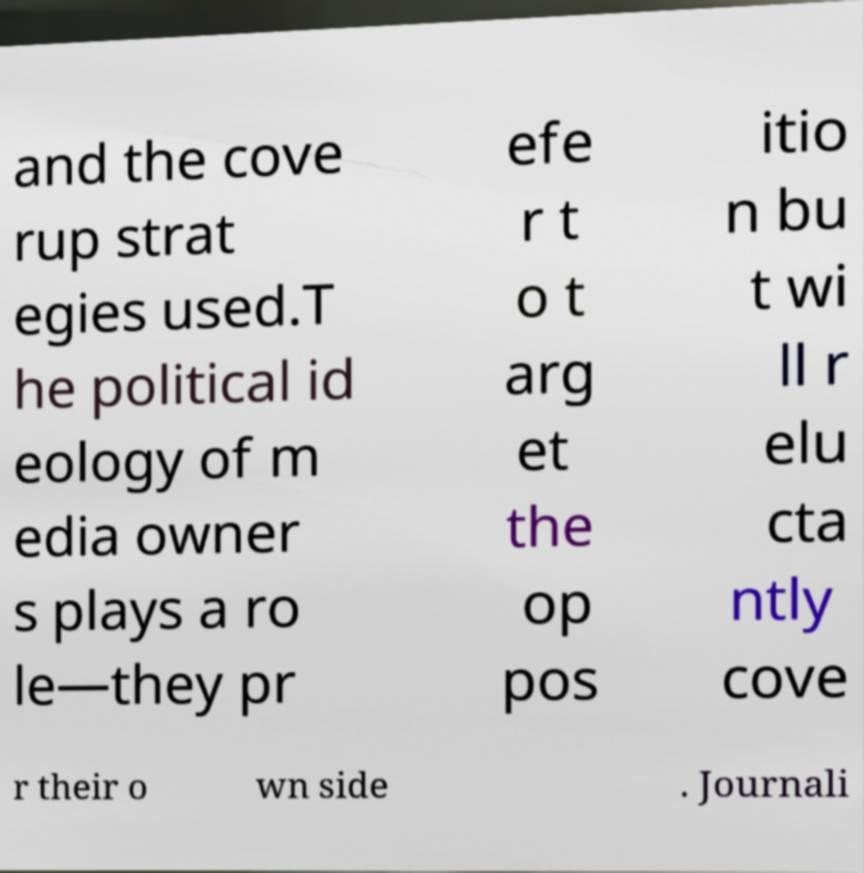What messages or text are displayed in this image? I need them in a readable, typed format. and the cove rup strat egies used.T he political id eology of m edia owner s plays a ro le—they pr efe r t o t arg et the op pos itio n bu t wi ll r elu cta ntly cove r their o wn side . Journali 